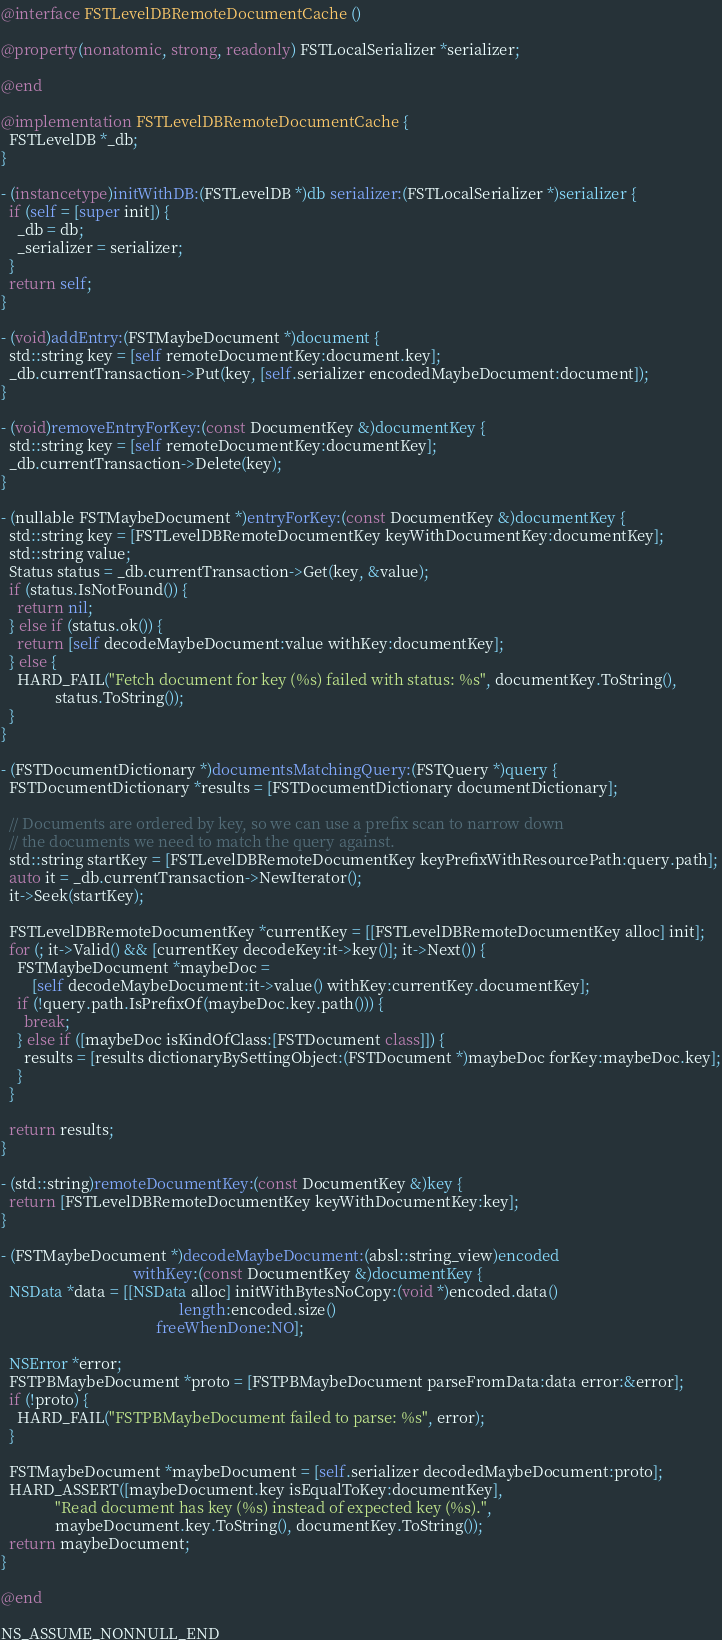<code> <loc_0><loc_0><loc_500><loc_500><_ObjectiveC_>@interface FSTLevelDBRemoteDocumentCache ()

@property(nonatomic, strong, readonly) FSTLocalSerializer *serializer;

@end

@implementation FSTLevelDBRemoteDocumentCache {
  FSTLevelDB *_db;
}

- (instancetype)initWithDB:(FSTLevelDB *)db serializer:(FSTLocalSerializer *)serializer {
  if (self = [super init]) {
    _db = db;
    _serializer = serializer;
  }
  return self;
}

- (void)addEntry:(FSTMaybeDocument *)document {
  std::string key = [self remoteDocumentKey:document.key];
  _db.currentTransaction->Put(key, [self.serializer encodedMaybeDocument:document]);
}

- (void)removeEntryForKey:(const DocumentKey &)documentKey {
  std::string key = [self remoteDocumentKey:documentKey];
  _db.currentTransaction->Delete(key);
}

- (nullable FSTMaybeDocument *)entryForKey:(const DocumentKey &)documentKey {
  std::string key = [FSTLevelDBRemoteDocumentKey keyWithDocumentKey:documentKey];
  std::string value;
  Status status = _db.currentTransaction->Get(key, &value);
  if (status.IsNotFound()) {
    return nil;
  } else if (status.ok()) {
    return [self decodeMaybeDocument:value withKey:documentKey];
  } else {
    HARD_FAIL("Fetch document for key (%s) failed with status: %s", documentKey.ToString(),
              status.ToString());
  }
}

- (FSTDocumentDictionary *)documentsMatchingQuery:(FSTQuery *)query {
  FSTDocumentDictionary *results = [FSTDocumentDictionary documentDictionary];

  // Documents are ordered by key, so we can use a prefix scan to narrow down
  // the documents we need to match the query against.
  std::string startKey = [FSTLevelDBRemoteDocumentKey keyPrefixWithResourcePath:query.path];
  auto it = _db.currentTransaction->NewIterator();
  it->Seek(startKey);

  FSTLevelDBRemoteDocumentKey *currentKey = [[FSTLevelDBRemoteDocumentKey alloc] init];
  for (; it->Valid() && [currentKey decodeKey:it->key()]; it->Next()) {
    FSTMaybeDocument *maybeDoc =
        [self decodeMaybeDocument:it->value() withKey:currentKey.documentKey];
    if (!query.path.IsPrefixOf(maybeDoc.key.path())) {
      break;
    } else if ([maybeDoc isKindOfClass:[FSTDocument class]]) {
      results = [results dictionaryBySettingObject:(FSTDocument *)maybeDoc forKey:maybeDoc.key];
    }
  }

  return results;
}

- (std::string)remoteDocumentKey:(const DocumentKey &)key {
  return [FSTLevelDBRemoteDocumentKey keyWithDocumentKey:key];
}

- (FSTMaybeDocument *)decodeMaybeDocument:(absl::string_view)encoded
                                  withKey:(const DocumentKey &)documentKey {
  NSData *data = [[NSData alloc] initWithBytesNoCopy:(void *)encoded.data()
                                              length:encoded.size()
                                        freeWhenDone:NO];

  NSError *error;
  FSTPBMaybeDocument *proto = [FSTPBMaybeDocument parseFromData:data error:&error];
  if (!proto) {
    HARD_FAIL("FSTPBMaybeDocument failed to parse: %s", error);
  }

  FSTMaybeDocument *maybeDocument = [self.serializer decodedMaybeDocument:proto];
  HARD_ASSERT([maybeDocument.key isEqualToKey:documentKey],
              "Read document has key (%s) instead of expected key (%s).",
              maybeDocument.key.ToString(), documentKey.ToString());
  return maybeDocument;
}

@end

NS_ASSUME_NONNULL_END
</code> 